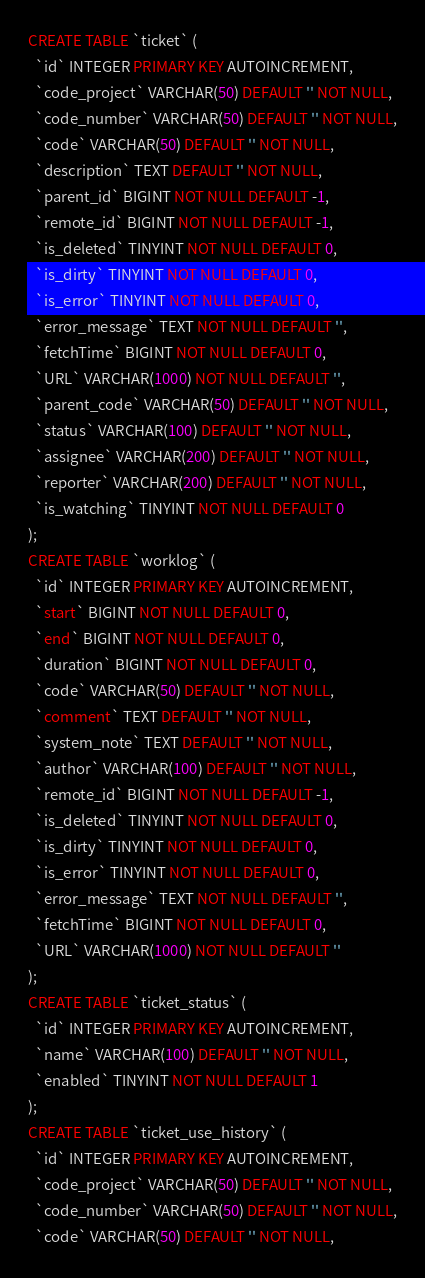<code> <loc_0><loc_0><loc_500><loc_500><_SQL_>CREATE TABLE `ticket` (
  `id` INTEGER PRIMARY KEY AUTOINCREMENT,
  `code_project` VARCHAR(50) DEFAULT '' NOT NULL,
  `code_number` VARCHAR(50) DEFAULT '' NOT NULL,
  `code` VARCHAR(50) DEFAULT '' NOT NULL,
  `description` TEXT DEFAULT '' NOT NULL,
  `parent_id` BIGINT NOT NULL DEFAULT -1,
  `remote_id` BIGINT NOT NULL DEFAULT -1,
  `is_deleted` TINYINT NOT NULL DEFAULT 0,
  `is_dirty` TINYINT NOT NULL DEFAULT 0,
  `is_error` TINYINT NOT NULL DEFAULT 0,
  `error_message` TEXT NOT NULL DEFAULT '',
  `fetchTime` BIGINT NOT NULL DEFAULT 0,
  `URL` VARCHAR(1000) NOT NULL DEFAULT '',
  `parent_code` VARCHAR(50) DEFAULT '' NOT NULL,
  `status` VARCHAR(100) DEFAULT '' NOT NULL,
  `assignee` VARCHAR(200) DEFAULT '' NOT NULL,
  `reporter` VARCHAR(200) DEFAULT '' NOT NULL,
  `is_watching` TINYINT NOT NULL DEFAULT 0
);
CREATE TABLE `worklog` (
  `id` INTEGER PRIMARY KEY AUTOINCREMENT,
  `start` BIGINT NOT NULL DEFAULT 0,
  `end` BIGINT NOT NULL DEFAULT 0,
  `duration` BIGINT NOT NULL DEFAULT 0,
  `code` VARCHAR(50) DEFAULT '' NOT NULL,
  `comment` TEXT DEFAULT '' NOT NULL,
  `system_note` TEXT DEFAULT '' NOT NULL,
  `author` VARCHAR(100) DEFAULT '' NOT NULL,
  `remote_id` BIGINT NOT NULL DEFAULT -1,
  `is_deleted` TINYINT NOT NULL DEFAULT 0,
  `is_dirty` TINYINT NOT NULL DEFAULT 0,
  `is_error` TINYINT NOT NULL DEFAULT 0,
  `error_message` TEXT NOT NULL DEFAULT '',
  `fetchTime` BIGINT NOT NULL DEFAULT 0,
  `URL` VARCHAR(1000) NOT NULL DEFAULT ''
);
CREATE TABLE `ticket_status` (
  `id` INTEGER PRIMARY KEY AUTOINCREMENT,
  `name` VARCHAR(100) DEFAULT '' NOT NULL,
  `enabled` TINYINT NOT NULL DEFAULT 1
);
CREATE TABLE `ticket_use_history` (
  `id` INTEGER PRIMARY KEY AUTOINCREMENT,
  `code_project` VARCHAR(50) DEFAULT '' NOT NULL,
  `code_number` VARCHAR(50) DEFAULT '' NOT NULL,
  `code` VARCHAR(50) DEFAULT '' NOT NULL,</code> 